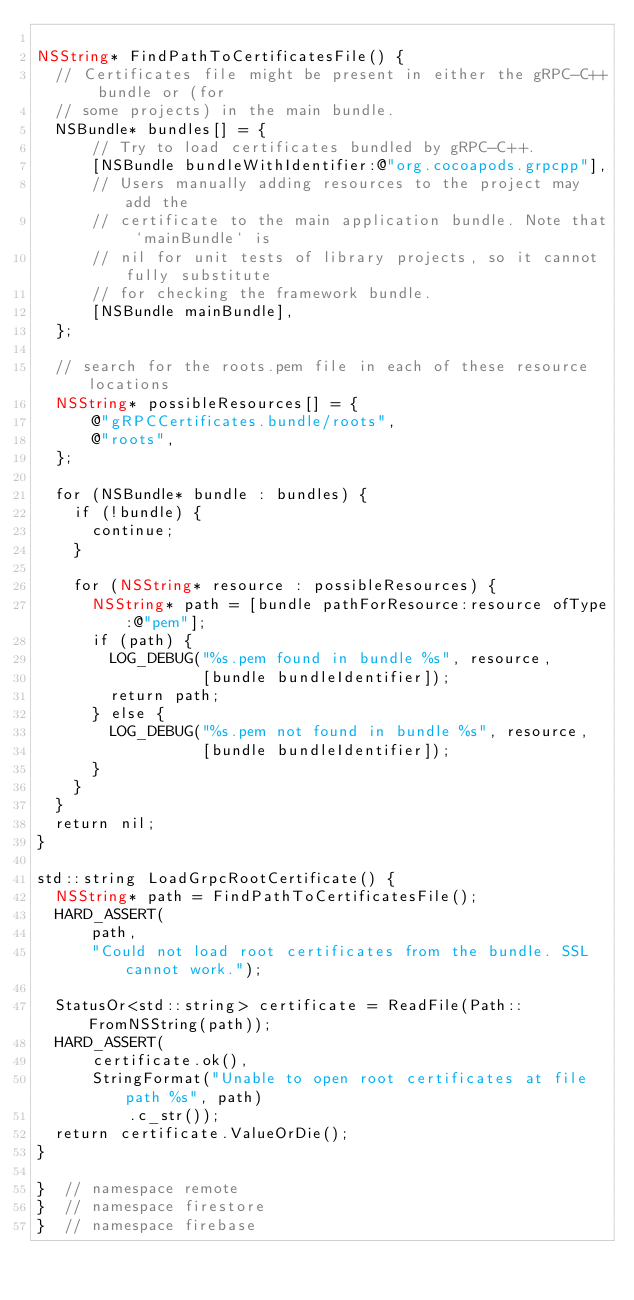Convert code to text. <code><loc_0><loc_0><loc_500><loc_500><_ObjectiveC_>
NSString* FindPathToCertificatesFile() {
  // Certificates file might be present in either the gRPC-C++ bundle or (for
  // some projects) in the main bundle.
  NSBundle* bundles[] = {
      // Try to load certificates bundled by gRPC-C++.
      [NSBundle bundleWithIdentifier:@"org.cocoapods.grpcpp"],
      // Users manually adding resources to the project may add the
      // certificate to the main application bundle. Note that `mainBundle` is
      // nil for unit tests of library projects, so it cannot fully substitute
      // for checking the framework bundle.
      [NSBundle mainBundle],
  };

  // search for the roots.pem file in each of these resource locations
  NSString* possibleResources[] = {
      @"gRPCCertificates.bundle/roots",
      @"roots",
  };

  for (NSBundle* bundle : bundles) {
    if (!bundle) {
      continue;
    }

    for (NSString* resource : possibleResources) {
      NSString* path = [bundle pathForResource:resource ofType:@"pem"];
      if (path) {
        LOG_DEBUG("%s.pem found in bundle %s", resource,
                  [bundle bundleIdentifier]);
        return path;
      } else {
        LOG_DEBUG("%s.pem not found in bundle %s", resource,
                  [bundle bundleIdentifier]);
      }
    }
  }
  return nil;
}

std::string LoadGrpcRootCertificate() {
  NSString* path = FindPathToCertificatesFile();
  HARD_ASSERT(
      path,
      "Could not load root certificates from the bundle. SSL cannot work.");

  StatusOr<std::string> certificate = ReadFile(Path::FromNSString(path));
  HARD_ASSERT(
      certificate.ok(),
      StringFormat("Unable to open root certificates at file path %s", path)
          .c_str());
  return certificate.ValueOrDie();
}

}  // namespace remote
}  // namespace firestore
}  // namespace firebase
</code> 